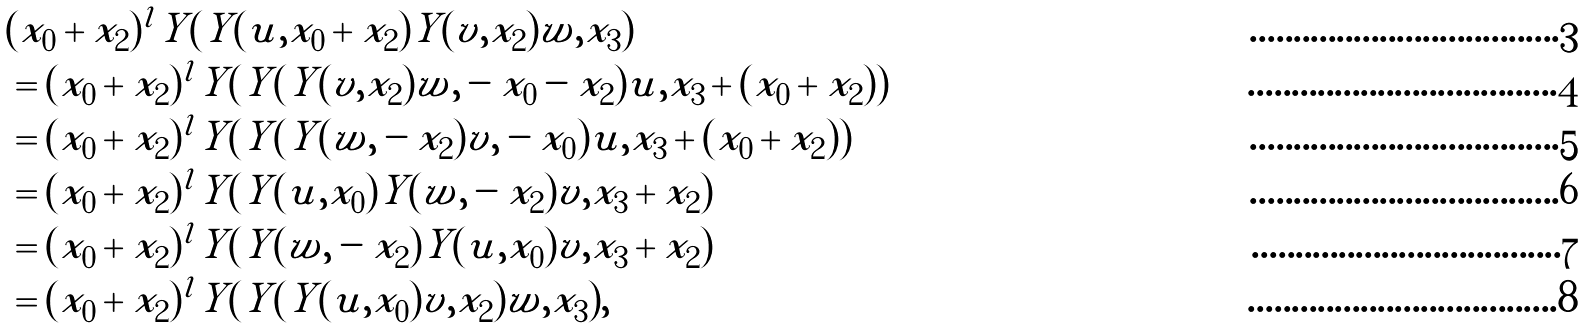<formula> <loc_0><loc_0><loc_500><loc_500>& ( x _ { 0 } + x _ { 2 } ) ^ { l } Y ( Y ( u , x _ { 0 } + x _ { 2 } ) Y ( v , x _ { 2 } ) w , x _ { 3 } ) \\ & = ( x _ { 0 } + x _ { 2 } ) ^ { l } Y ( Y ( Y ( v , x _ { 2 } ) w , - x _ { 0 } - x _ { 2 } ) u , x _ { 3 } + ( x _ { 0 } + x _ { 2 } ) ) \\ & = ( x _ { 0 } + x _ { 2 } ) ^ { l } Y ( Y ( Y ( w , - x _ { 2 } ) v , - x _ { 0 } ) u , x _ { 3 } + ( x _ { 0 } + x _ { 2 } ) ) \\ & = ( x _ { 0 } + x _ { 2 } ) ^ { l } Y ( Y ( u , x _ { 0 } ) Y ( w , - x _ { 2 } ) v , x _ { 3 } + x _ { 2 } ) \\ & = ( x _ { 0 } + x _ { 2 } ) ^ { l } Y ( Y ( w , - x _ { 2 } ) Y ( u , x _ { 0 } ) v , x _ { 3 } + x _ { 2 } ) \\ & = ( x _ { 0 } + x _ { 2 } ) ^ { l } Y ( Y ( Y ( u , x _ { 0 } ) v , x _ { 2 } ) w , x _ { 3 } ) ,</formula> 